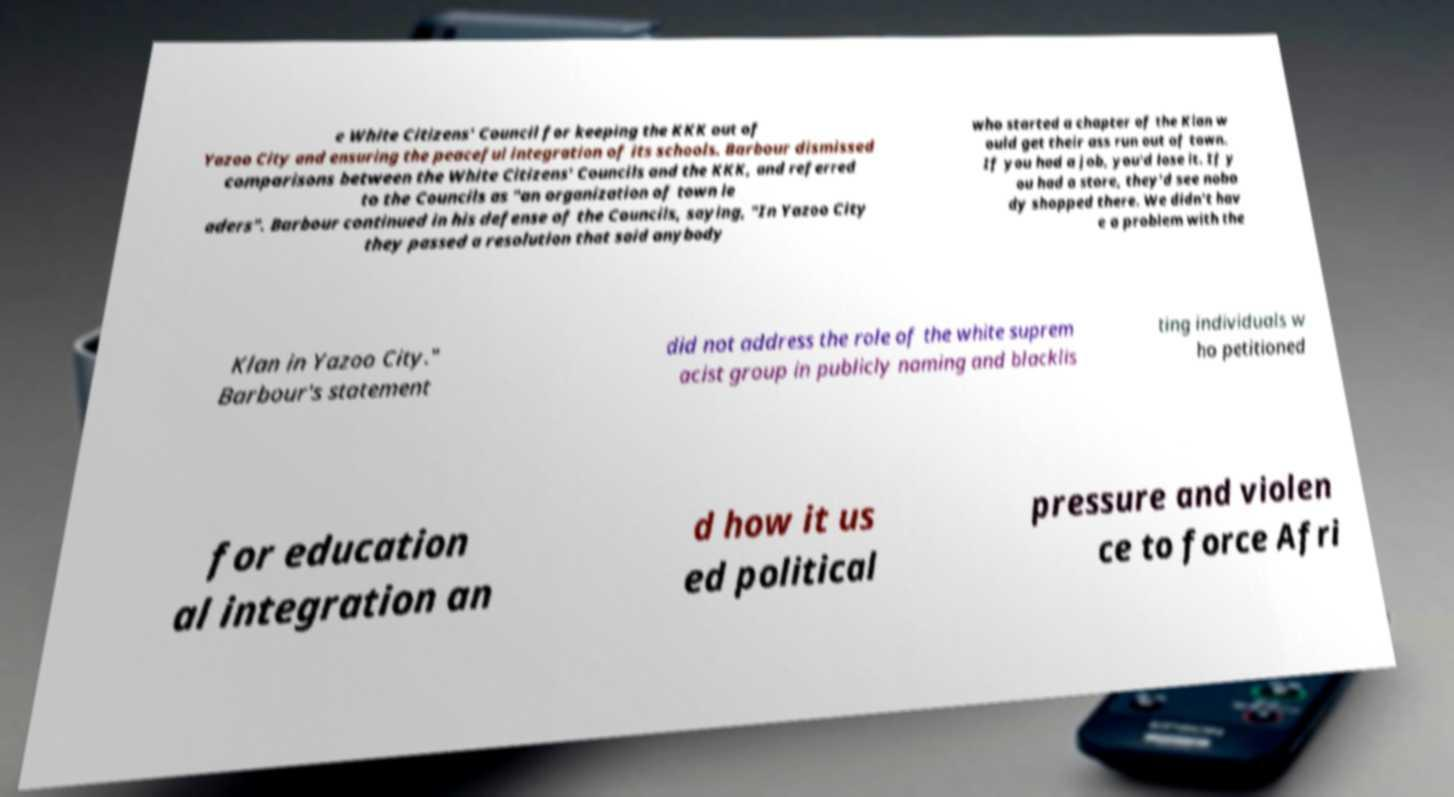Could you assist in decoding the text presented in this image and type it out clearly? e White Citizens' Council for keeping the KKK out of Yazoo City and ensuring the peaceful integration of its schools. Barbour dismissed comparisons between the White Citizens' Councils and the KKK, and referred to the Councils as "an organization of town le aders". Barbour continued in his defense of the Councils, saying, "In Yazoo City they passed a resolution that said anybody who started a chapter of the Klan w ould get their ass run out of town. If you had a job, you'd lose it. If y ou had a store, they'd see nobo dy shopped there. We didn't hav e a problem with the Klan in Yazoo City." Barbour's statement did not address the role of the white suprem acist group in publicly naming and blacklis ting individuals w ho petitioned for education al integration an d how it us ed political pressure and violen ce to force Afri 